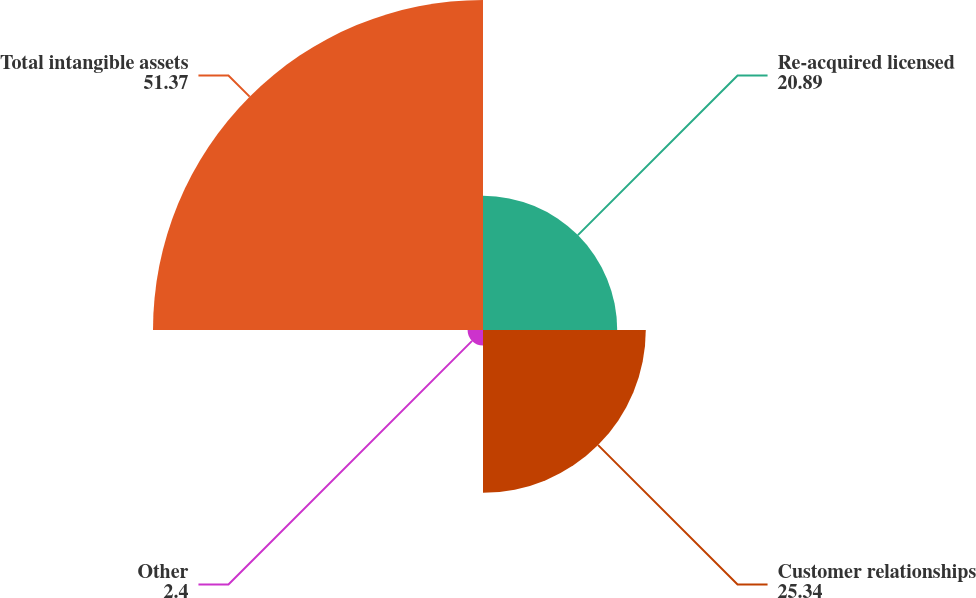<chart> <loc_0><loc_0><loc_500><loc_500><pie_chart><fcel>Re-acquired licensed<fcel>Customer relationships<fcel>Other<fcel>Total intangible assets<nl><fcel>20.89%<fcel>25.34%<fcel>2.4%<fcel>51.37%<nl></chart> 